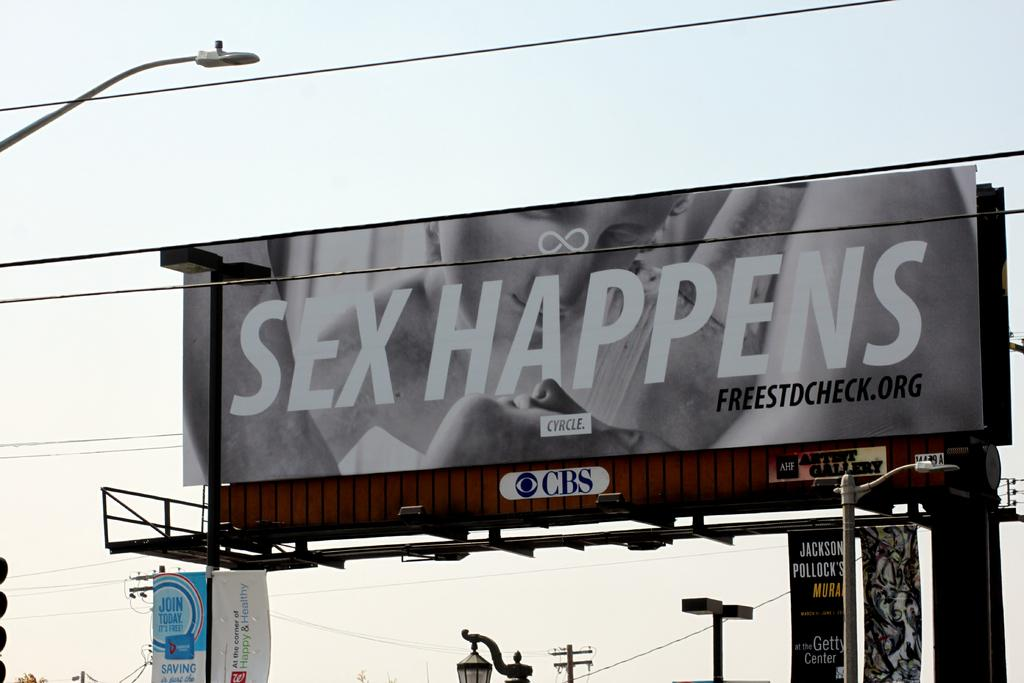<image>
Create a compact narrative representing the image presented. A sex positive billboard advertising sex happens sits above a street. 